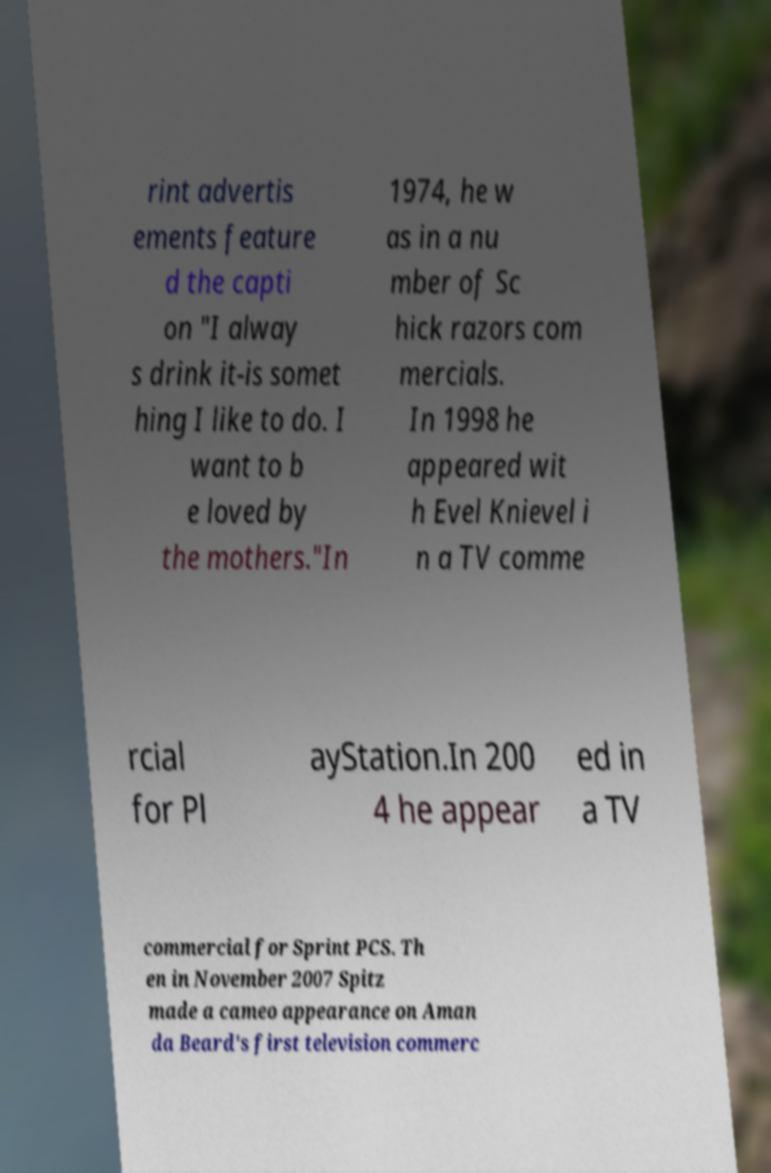I need the written content from this picture converted into text. Can you do that? rint advertis ements feature d the capti on "I alway s drink it-is somet hing I like to do. I want to b e loved by the mothers."In 1974, he w as in a nu mber of Sc hick razors com mercials. In 1998 he appeared wit h Evel Knievel i n a TV comme rcial for Pl ayStation.In 200 4 he appear ed in a TV commercial for Sprint PCS. Th en in November 2007 Spitz made a cameo appearance on Aman da Beard's first television commerc 